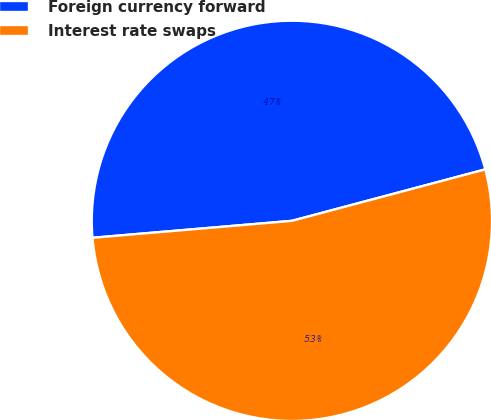Convert chart. <chart><loc_0><loc_0><loc_500><loc_500><pie_chart><fcel>Foreign currency forward<fcel>Interest rate swaps<nl><fcel>47.21%<fcel>52.79%<nl></chart> 